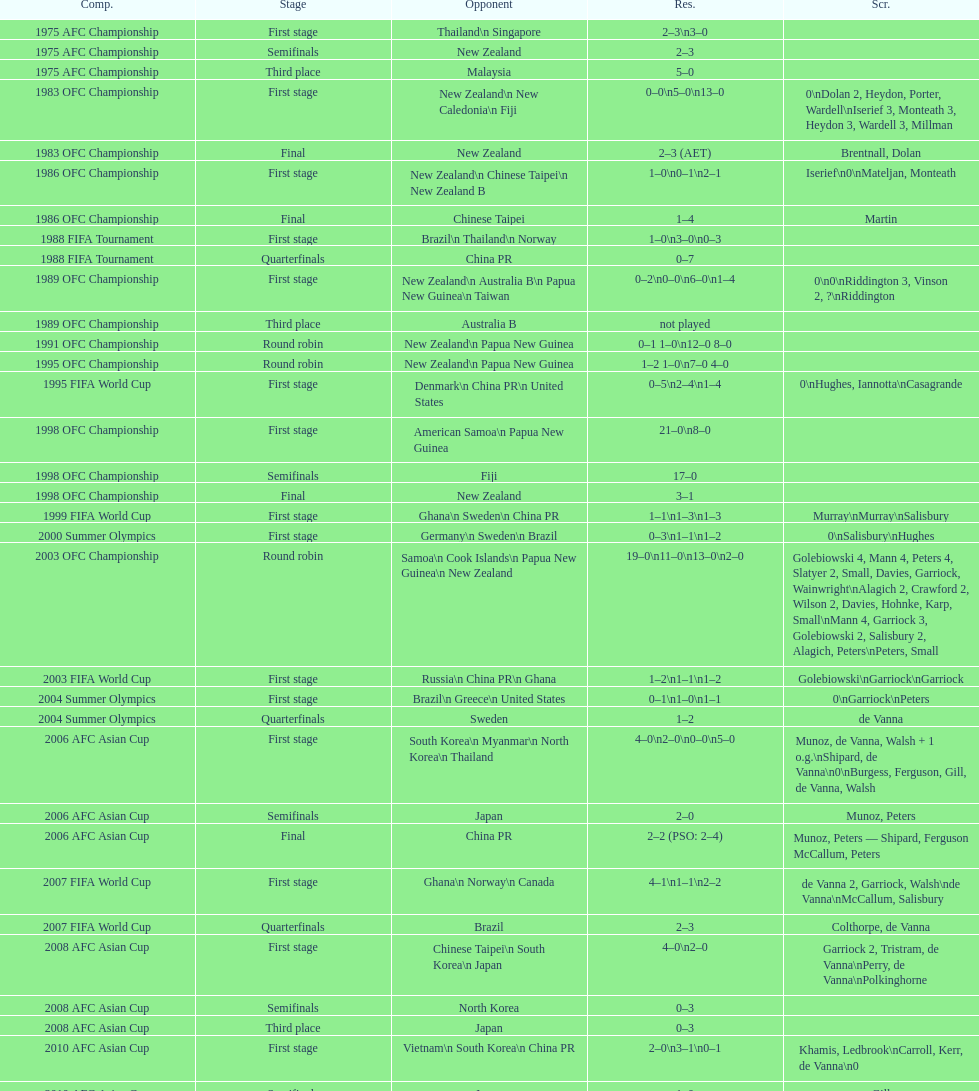What is the difference in the number of goals scored in the 1999 fifa world cup and the 2000 summer olympics? 2. 